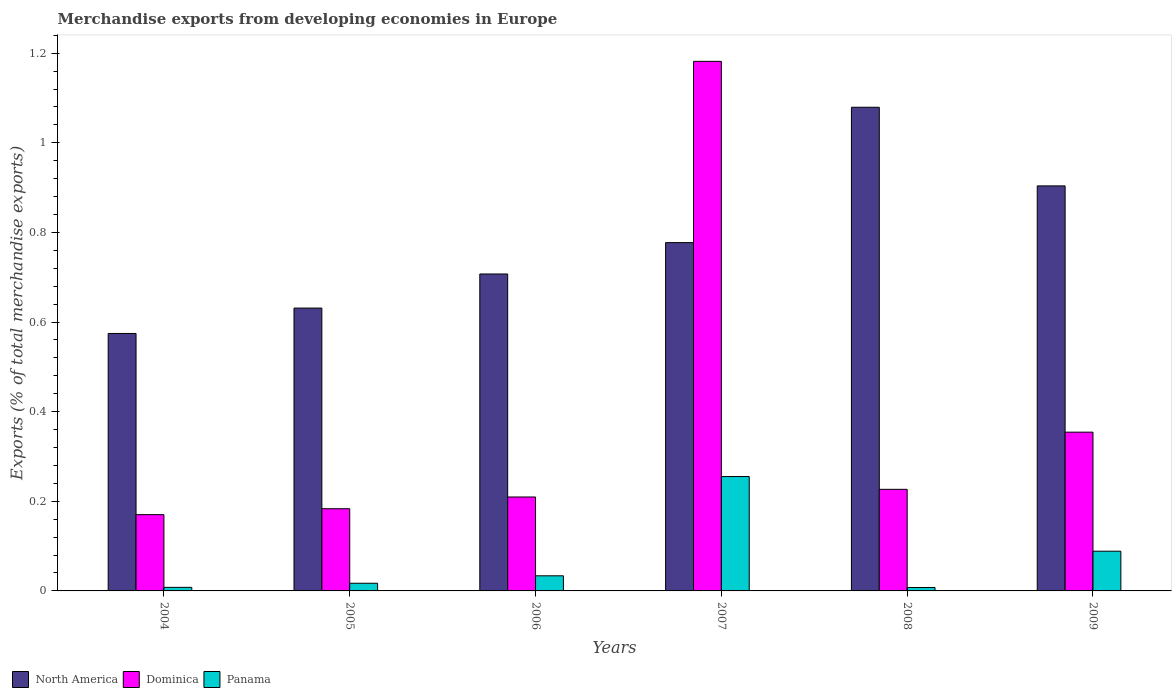Are the number of bars on each tick of the X-axis equal?
Give a very brief answer. Yes. How many bars are there on the 6th tick from the left?
Make the answer very short. 3. How many bars are there on the 6th tick from the right?
Your answer should be compact. 3. What is the percentage of total merchandise exports in Panama in 2007?
Give a very brief answer. 0.26. Across all years, what is the maximum percentage of total merchandise exports in Dominica?
Provide a short and direct response. 1.18. Across all years, what is the minimum percentage of total merchandise exports in Panama?
Provide a short and direct response. 0.01. In which year was the percentage of total merchandise exports in Dominica maximum?
Make the answer very short. 2007. What is the total percentage of total merchandise exports in Panama in the graph?
Provide a succinct answer. 0.41. What is the difference between the percentage of total merchandise exports in North America in 2006 and that in 2009?
Your response must be concise. -0.2. What is the difference between the percentage of total merchandise exports in Dominica in 2008 and the percentage of total merchandise exports in Panama in 2009?
Keep it short and to the point. 0.14. What is the average percentage of total merchandise exports in Dominica per year?
Offer a terse response. 0.39. In the year 2004, what is the difference between the percentage of total merchandise exports in Dominica and percentage of total merchandise exports in Panama?
Ensure brevity in your answer.  0.16. In how many years, is the percentage of total merchandise exports in North America greater than 1 %?
Provide a succinct answer. 1. What is the ratio of the percentage of total merchandise exports in North America in 2004 to that in 2005?
Your answer should be very brief. 0.91. Is the percentage of total merchandise exports in North America in 2005 less than that in 2008?
Your response must be concise. Yes. What is the difference between the highest and the second highest percentage of total merchandise exports in Dominica?
Provide a short and direct response. 0.83. What is the difference between the highest and the lowest percentage of total merchandise exports in Panama?
Offer a terse response. 0.25. In how many years, is the percentage of total merchandise exports in North America greater than the average percentage of total merchandise exports in North America taken over all years?
Offer a very short reply. 2. What does the 2nd bar from the right in 2007 represents?
Provide a succinct answer. Dominica. How many bars are there?
Your answer should be very brief. 18. How many years are there in the graph?
Offer a terse response. 6. What is the difference between two consecutive major ticks on the Y-axis?
Give a very brief answer. 0.2. Are the values on the major ticks of Y-axis written in scientific E-notation?
Offer a terse response. No. Does the graph contain any zero values?
Your answer should be very brief. No. Where does the legend appear in the graph?
Make the answer very short. Bottom left. How many legend labels are there?
Give a very brief answer. 3. How are the legend labels stacked?
Provide a succinct answer. Horizontal. What is the title of the graph?
Give a very brief answer. Merchandise exports from developing economies in Europe. Does "Small states" appear as one of the legend labels in the graph?
Provide a succinct answer. No. What is the label or title of the X-axis?
Give a very brief answer. Years. What is the label or title of the Y-axis?
Your answer should be very brief. Exports (% of total merchandise exports). What is the Exports (% of total merchandise exports) of North America in 2004?
Your answer should be very brief. 0.57. What is the Exports (% of total merchandise exports) of Dominica in 2004?
Your answer should be very brief. 0.17. What is the Exports (% of total merchandise exports) of Panama in 2004?
Make the answer very short. 0.01. What is the Exports (% of total merchandise exports) of North America in 2005?
Ensure brevity in your answer.  0.63. What is the Exports (% of total merchandise exports) of Dominica in 2005?
Ensure brevity in your answer.  0.18. What is the Exports (% of total merchandise exports) in Panama in 2005?
Make the answer very short. 0.02. What is the Exports (% of total merchandise exports) of North America in 2006?
Your answer should be very brief. 0.71. What is the Exports (% of total merchandise exports) of Dominica in 2006?
Offer a very short reply. 0.21. What is the Exports (% of total merchandise exports) in Panama in 2006?
Provide a short and direct response. 0.03. What is the Exports (% of total merchandise exports) in North America in 2007?
Ensure brevity in your answer.  0.78. What is the Exports (% of total merchandise exports) in Dominica in 2007?
Offer a very short reply. 1.18. What is the Exports (% of total merchandise exports) of Panama in 2007?
Keep it short and to the point. 0.26. What is the Exports (% of total merchandise exports) of North America in 2008?
Your answer should be very brief. 1.08. What is the Exports (% of total merchandise exports) of Dominica in 2008?
Provide a succinct answer. 0.23. What is the Exports (% of total merchandise exports) in Panama in 2008?
Give a very brief answer. 0.01. What is the Exports (% of total merchandise exports) of North America in 2009?
Provide a succinct answer. 0.9. What is the Exports (% of total merchandise exports) in Dominica in 2009?
Your response must be concise. 0.35. What is the Exports (% of total merchandise exports) in Panama in 2009?
Ensure brevity in your answer.  0.09. Across all years, what is the maximum Exports (% of total merchandise exports) in North America?
Keep it short and to the point. 1.08. Across all years, what is the maximum Exports (% of total merchandise exports) of Dominica?
Keep it short and to the point. 1.18. Across all years, what is the maximum Exports (% of total merchandise exports) in Panama?
Give a very brief answer. 0.26. Across all years, what is the minimum Exports (% of total merchandise exports) in North America?
Your answer should be very brief. 0.57. Across all years, what is the minimum Exports (% of total merchandise exports) of Dominica?
Keep it short and to the point. 0.17. Across all years, what is the minimum Exports (% of total merchandise exports) in Panama?
Your answer should be very brief. 0.01. What is the total Exports (% of total merchandise exports) in North America in the graph?
Give a very brief answer. 4.67. What is the total Exports (% of total merchandise exports) of Dominica in the graph?
Your answer should be compact. 2.33. What is the total Exports (% of total merchandise exports) of Panama in the graph?
Ensure brevity in your answer.  0.41. What is the difference between the Exports (% of total merchandise exports) in North America in 2004 and that in 2005?
Your response must be concise. -0.06. What is the difference between the Exports (% of total merchandise exports) of Dominica in 2004 and that in 2005?
Offer a terse response. -0.01. What is the difference between the Exports (% of total merchandise exports) of Panama in 2004 and that in 2005?
Your response must be concise. -0.01. What is the difference between the Exports (% of total merchandise exports) in North America in 2004 and that in 2006?
Offer a terse response. -0.13. What is the difference between the Exports (% of total merchandise exports) of Dominica in 2004 and that in 2006?
Offer a very short reply. -0.04. What is the difference between the Exports (% of total merchandise exports) of Panama in 2004 and that in 2006?
Provide a short and direct response. -0.03. What is the difference between the Exports (% of total merchandise exports) in North America in 2004 and that in 2007?
Your answer should be very brief. -0.2. What is the difference between the Exports (% of total merchandise exports) in Dominica in 2004 and that in 2007?
Offer a very short reply. -1.01. What is the difference between the Exports (% of total merchandise exports) in Panama in 2004 and that in 2007?
Offer a terse response. -0.25. What is the difference between the Exports (% of total merchandise exports) of North America in 2004 and that in 2008?
Provide a short and direct response. -0.5. What is the difference between the Exports (% of total merchandise exports) in Dominica in 2004 and that in 2008?
Provide a succinct answer. -0.06. What is the difference between the Exports (% of total merchandise exports) in North America in 2004 and that in 2009?
Give a very brief answer. -0.33. What is the difference between the Exports (% of total merchandise exports) of Dominica in 2004 and that in 2009?
Your answer should be very brief. -0.18. What is the difference between the Exports (% of total merchandise exports) of Panama in 2004 and that in 2009?
Keep it short and to the point. -0.08. What is the difference between the Exports (% of total merchandise exports) in North America in 2005 and that in 2006?
Your answer should be very brief. -0.08. What is the difference between the Exports (% of total merchandise exports) of Dominica in 2005 and that in 2006?
Your answer should be compact. -0.03. What is the difference between the Exports (% of total merchandise exports) in Panama in 2005 and that in 2006?
Make the answer very short. -0.02. What is the difference between the Exports (% of total merchandise exports) of North America in 2005 and that in 2007?
Make the answer very short. -0.15. What is the difference between the Exports (% of total merchandise exports) in Dominica in 2005 and that in 2007?
Offer a very short reply. -1. What is the difference between the Exports (% of total merchandise exports) of Panama in 2005 and that in 2007?
Your response must be concise. -0.24. What is the difference between the Exports (% of total merchandise exports) in North America in 2005 and that in 2008?
Your answer should be compact. -0.45. What is the difference between the Exports (% of total merchandise exports) of Dominica in 2005 and that in 2008?
Give a very brief answer. -0.04. What is the difference between the Exports (% of total merchandise exports) of Panama in 2005 and that in 2008?
Your answer should be very brief. 0.01. What is the difference between the Exports (% of total merchandise exports) of North America in 2005 and that in 2009?
Your answer should be very brief. -0.27. What is the difference between the Exports (% of total merchandise exports) in Dominica in 2005 and that in 2009?
Provide a succinct answer. -0.17. What is the difference between the Exports (% of total merchandise exports) in Panama in 2005 and that in 2009?
Keep it short and to the point. -0.07. What is the difference between the Exports (% of total merchandise exports) of North America in 2006 and that in 2007?
Offer a very short reply. -0.07. What is the difference between the Exports (% of total merchandise exports) of Dominica in 2006 and that in 2007?
Provide a succinct answer. -0.97. What is the difference between the Exports (% of total merchandise exports) in Panama in 2006 and that in 2007?
Keep it short and to the point. -0.22. What is the difference between the Exports (% of total merchandise exports) of North America in 2006 and that in 2008?
Provide a short and direct response. -0.37. What is the difference between the Exports (% of total merchandise exports) of Dominica in 2006 and that in 2008?
Offer a terse response. -0.02. What is the difference between the Exports (% of total merchandise exports) of Panama in 2006 and that in 2008?
Keep it short and to the point. 0.03. What is the difference between the Exports (% of total merchandise exports) of North America in 2006 and that in 2009?
Provide a short and direct response. -0.2. What is the difference between the Exports (% of total merchandise exports) of Dominica in 2006 and that in 2009?
Provide a succinct answer. -0.14. What is the difference between the Exports (% of total merchandise exports) in Panama in 2006 and that in 2009?
Make the answer very short. -0.05. What is the difference between the Exports (% of total merchandise exports) of North America in 2007 and that in 2008?
Your answer should be compact. -0.3. What is the difference between the Exports (% of total merchandise exports) in Dominica in 2007 and that in 2008?
Provide a short and direct response. 0.96. What is the difference between the Exports (% of total merchandise exports) in Panama in 2007 and that in 2008?
Make the answer very short. 0.25. What is the difference between the Exports (% of total merchandise exports) in North America in 2007 and that in 2009?
Your answer should be very brief. -0.13. What is the difference between the Exports (% of total merchandise exports) in Dominica in 2007 and that in 2009?
Provide a succinct answer. 0.83. What is the difference between the Exports (% of total merchandise exports) in Panama in 2007 and that in 2009?
Give a very brief answer. 0.17. What is the difference between the Exports (% of total merchandise exports) of North America in 2008 and that in 2009?
Give a very brief answer. 0.18. What is the difference between the Exports (% of total merchandise exports) of Dominica in 2008 and that in 2009?
Provide a succinct answer. -0.13. What is the difference between the Exports (% of total merchandise exports) of Panama in 2008 and that in 2009?
Provide a short and direct response. -0.08. What is the difference between the Exports (% of total merchandise exports) in North America in 2004 and the Exports (% of total merchandise exports) in Dominica in 2005?
Provide a short and direct response. 0.39. What is the difference between the Exports (% of total merchandise exports) in North America in 2004 and the Exports (% of total merchandise exports) in Panama in 2005?
Provide a short and direct response. 0.56. What is the difference between the Exports (% of total merchandise exports) in Dominica in 2004 and the Exports (% of total merchandise exports) in Panama in 2005?
Provide a succinct answer. 0.15. What is the difference between the Exports (% of total merchandise exports) of North America in 2004 and the Exports (% of total merchandise exports) of Dominica in 2006?
Your answer should be compact. 0.36. What is the difference between the Exports (% of total merchandise exports) in North America in 2004 and the Exports (% of total merchandise exports) in Panama in 2006?
Ensure brevity in your answer.  0.54. What is the difference between the Exports (% of total merchandise exports) of Dominica in 2004 and the Exports (% of total merchandise exports) of Panama in 2006?
Your answer should be very brief. 0.14. What is the difference between the Exports (% of total merchandise exports) of North America in 2004 and the Exports (% of total merchandise exports) of Dominica in 2007?
Provide a succinct answer. -0.61. What is the difference between the Exports (% of total merchandise exports) in North America in 2004 and the Exports (% of total merchandise exports) in Panama in 2007?
Provide a succinct answer. 0.32. What is the difference between the Exports (% of total merchandise exports) of Dominica in 2004 and the Exports (% of total merchandise exports) of Panama in 2007?
Keep it short and to the point. -0.09. What is the difference between the Exports (% of total merchandise exports) of North America in 2004 and the Exports (% of total merchandise exports) of Dominica in 2008?
Offer a terse response. 0.35. What is the difference between the Exports (% of total merchandise exports) of North America in 2004 and the Exports (% of total merchandise exports) of Panama in 2008?
Your answer should be very brief. 0.57. What is the difference between the Exports (% of total merchandise exports) of Dominica in 2004 and the Exports (% of total merchandise exports) of Panama in 2008?
Offer a very short reply. 0.16. What is the difference between the Exports (% of total merchandise exports) of North America in 2004 and the Exports (% of total merchandise exports) of Dominica in 2009?
Make the answer very short. 0.22. What is the difference between the Exports (% of total merchandise exports) of North America in 2004 and the Exports (% of total merchandise exports) of Panama in 2009?
Offer a terse response. 0.49. What is the difference between the Exports (% of total merchandise exports) of Dominica in 2004 and the Exports (% of total merchandise exports) of Panama in 2009?
Your answer should be very brief. 0.08. What is the difference between the Exports (% of total merchandise exports) in North America in 2005 and the Exports (% of total merchandise exports) in Dominica in 2006?
Offer a terse response. 0.42. What is the difference between the Exports (% of total merchandise exports) of North America in 2005 and the Exports (% of total merchandise exports) of Panama in 2006?
Keep it short and to the point. 0.6. What is the difference between the Exports (% of total merchandise exports) of Dominica in 2005 and the Exports (% of total merchandise exports) of Panama in 2006?
Give a very brief answer. 0.15. What is the difference between the Exports (% of total merchandise exports) of North America in 2005 and the Exports (% of total merchandise exports) of Dominica in 2007?
Your response must be concise. -0.55. What is the difference between the Exports (% of total merchandise exports) of North America in 2005 and the Exports (% of total merchandise exports) of Panama in 2007?
Offer a very short reply. 0.38. What is the difference between the Exports (% of total merchandise exports) of Dominica in 2005 and the Exports (% of total merchandise exports) of Panama in 2007?
Make the answer very short. -0.07. What is the difference between the Exports (% of total merchandise exports) in North America in 2005 and the Exports (% of total merchandise exports) in Dominica in 2008?
Provide a succinct answer. 0.4. What is the difference between the Exports (% of total merchandise exports) in North America in 2005 and the Exports (% of total merchandise exports) in Panama in 2008?
Your answer should be compact. 0.62. What is the difference between the Exports (% of total merchandise exports) in Dominica in 2005 and the Exports (% of total merchandise exports) in Panama in 2008?
Keep it short and to the point. 0.18. What is the difference between the Exports (% of total merchandise exports) in North America in 2005 and the Exports (% of total merchandise exports) in Dominica in 2009?
Keep it short and to the point. 0.28. What is the difference between the Exports (% of total merchandise exports) of North America in 2005 and the Exports (% of total merchandise exports) of Panama in 2009?
Keep it short and to the point. 0.54. What is the difference between the Exports (% of total merchandise exports) in Dominica in 2005 and the Exports (% of total merchandise exports) in Panama in 2009?
Make the answer very short. 0.09. What is the difference between the Exports (% of total merchandise exports) of North America in 2006 and the Exports (% of total merchandise exports) of Dominica in 2007?
Provide a short and direct response. -0.47. What is the difference between the Exports (% of total merchandise exports) of North America in 2006 and the Exports (% of total merchandise exports) of Panama in 2007?
Make the answer very short. 0.45. What is the difference between the Exports (% of total merchandise exports) of Dominica in 2006 and the Exports (% of total merchandise exports) of Panama in 2007?
Keep it short and to the point. -0.05. What is the difference between the Exports (% of total merchandise exports) of North America in 2006 and the Exports (% of total merchandise exports) of Dominica in 2008?
Offer a very short reply. 0.48. What is the difference between the Exports (% of total merchandise exports) in North America in 2006 and the Exports (% of total merchandise exports) in Panama in 2008?
Your response must be concise. 0.7. What is the difference between the Exports (% of total merchandise exports) in Dominica in 2006 and the Exports (% of total merchandise exports) in Panama in 2008?
Your answer should be very brief. 0.2. What is the difference between the Exports (% of total merchandise exports) in North America in 2006 and the Exports (% of total merchandise exports) in Dominica in 2009?
Make the answer very short. 0.35. What is the difference between the Exports (% of total merchandise exports) of North America in 2006 and the Exports (% of total merchandise exports) of Panama in 2009?
Offer a terse response. 0.62. What is the difference between the Exports (% of total merchandise exports) in Dominica in 2006 and the Exports (% of total merchandise exports) in Panama in 2009?
Keep it short and to the point. 0.12. What is the difference between the Exports (% of total merchandise exports) in North America in 2007 and the Exports (% of total merchandise exports) in Dominica in 2008?
Make the answer very short. 0.55. What is the difference between the Exports (% of total merchandise exports) in North America in 2007 and the Exports (% of total merchandise exports) in Panama in 2008?
Provide a succinct answer. 0.77. What is the difference between the Exports (% of total merchandise exports) of Dominica in 2007 and the Exports (% of total merchandise exports) of Panama in 2008?
Your answer should be compact. 1.17. What is the difference between the Exports (% of total merchandise exports) in North America in 2007 and the Exports (% of total merchandise exports) in Dominica in 2009?
Your answer should be compact. 0.42. What is the difference between the Exports (% of total merchandise exports) in North America in 2007 and the Exports (% of total merchandise exports) in Panama in 2009?
Offer a very short reply. 0.69. What is the difference between the Exports (% of total merchandise exports) in Dominica in 2007 and the Exports (% of total merchandise exports) in Panama in 2009?
Your answer should be very brief. 1.09. What is the difference between the Exports (% of total merchandise exports) in North America in 2008 and the Exports (% of total merchandise exports) in Dominica in 2009?
Provide a short and direct response. 0.73. What is the difference between the Exports (% of total merchandise exports) in North America in 2008 and the Exports (% of total merchandise exports) in Panama in 2009?
Provide a succinct answer. 0.99. What is the difference between the Exports (% of total merchandise exports) in Dominica in 2008 and the Exports (% of total merchandise exports) in Panama in 2009?
Your answer should be compact. 0.14. What is the average Exports (% of total merchandise exports) of North America per year?
Offer a very short reply. 0.78. What is the average Exports (% of total merchandise exports) of Dominica per year?
Your answer should be compact. 0.39. What is the average Exports (% of total merchandise exports) of Panama per year?
Provide a succinct answer. 0.07. In the year 2004, what is the difference between the Exports (% of total merchandise exports) in North America and Exports (% of total merchandise exports) in Dominica?
Your response must be concise. 0.4. In the year 2004, what is the difference between the Exports (% of total merchandise exports) in North America and Exports (% of total merchandise exports) in Panama?
Offer a very short reply. 0.57. In the year 2004, what is the difference between the Exports (% of total merchandise exports) of Dominica and Exports (% of total merchandise exports) of Panama?
Offer a very short reply. 0.16. In the year 2005, what is the difference between the Exports (% of total merchandise exports) in North America and Exports (% of total merchandise exports) in Dominica?
Provide a short and direct response. 0.45. In the year 2005, what is the difference between the Exports (% of total merchandise exports) in North America and Exports (% of total merchandise exports) in Panama?
Your response must be concise. 0.61. In the year 2005, what is the difference between the Exports (% of total merchandise exports) of Dominica and Exports (% of total merchandise exports) of Panama?
Your response must be concise. 0.17. In the year 2006, what is the difference between the Exports (% of total merchandise exports) in North America and Exports (% of total merchandise exports) in Dominica?
Make the answer very short. 0.5. In the year 2006, what is the difference between the Exports (% of total merchandise exports) in North America and Exports (% of total merchandise exports) in Panama?
Give a very brief answer. 0.67. In the year 2006, what is the difference between the Exports (% of total merchandise exports) of Dominica and Exports (% of total merchandise exports) of Panama?
Provide a succinct answer. 0.18. In the year 2007, what is the difference between the Exports (% of total merchandise exports) of North America and Exports (% of total merchandise exports) of Dominica?
Your response must be concise. -0.4. In the year 2007, what is the difference between the Exports (% of total merchandise exports) of North America and Exports (% of total merchandise exports) of Panama?
Ensure brevity in your answer.  0.52. In the year 2007, what is the difference between the Exports (% of total merchandise exports) of Dominica and Exports (% of total merchandise exports) of Panama?
Ensure brevity in your answer.  0.93. In the year 2008, what is the difference between the Exports (% of total merchandise exports) in North America and Exports (% of total merchandise exports) in Dominica?
Provide a short and direct response. 0.85. In the year 2008, what is the difference between the Exports (% of total merchandise exports) of North America and Exports (% of total merchandise exports) of Panama?
Your answer should be compact. 1.07. In the year 2008, what is the difference between the Exports (% of total merchandise exports) in Dominica and Exports (% of total merchandise exports) in Panama?
Your response must be concise. 0.22. In the year 2009, what is the difference between the Exports (% of total merchandise exports) of North America and Exports (% of total merchandise exports) of Dominica?
Offer a very short reply. 0.55. In the year 2009, what is the difference between the Exports (% of total merchandise exports) of North America and Exports (% of total merchandise exports) of Panama?
Make the answer very short. 0.82. In the year 2009, what is the difference between the Exports (% of total merchandise exports) in Dominica and Exports (% of total merchandise exports) in Panama?
Your response must be concise. 0.27. What is the ratio of the Exports (% of total merchandise exports) in North America in 2004 to that in 2005?
Offer a very short reply. 0.91. What is the ratio of the Exports (% of total merchandise exports) in Dominica in 2004 to that in 2005?
Your response must be concise. 0.93. What is the ratio of the Exports (% of total merchandise exports) of Panama in 2004 to that in 2005?
Your answer should be compact. 0.47. What is the ratio of the Exports (% of total merchandise exports) of North America in 2004 to that in 2006?
Make the answer very short. 0.81. What is the ratio of the Exports (% of total merchandise exports) of Dominica in 2004 to that in 2006?
Provide a short and direct response. 0.81. What is the ratio of the Exports (% of total merchandise exports) of Panama in 2004 to that in 2006?
Offer a terse response. 0.24. What is the ratio of the Exports (% of total merchandise exports) of North America in 2004 to that in 2007?
Give a very brief answer. 0.74. What is the ratio of the Exports (% of total merchandise exports) in Dominica in 2004 to that in 2007?
Give a very brief answer. 0.14. What is the ratio of the Exports (% of total merchandise exports) in Panama in 2004 to that in 2007?
Offer a terse response. 0.03. What is the ratio of the Exports (% of total merchandise exports) in North America in 2004 to that in 2008?
Make the answer very short. 0.53. What is the ratio of the Exports (% of total merchandise exports) in Dominica in 2004 to that in 2008?
Make the answer very short. 0.75. What is the ratio of the Exports (% of total merchandise exports) in Panama in 2004 to that in 2008?
Provide a succinct answer. 1.04. What is the ratio of the Exports (% of total merchandise exports) of North America in 2004 to that in 2009?
Make the answer very short. 0.64. What is the ratio of the Exports (% of total merchandise exports) of Dominica in 2004 to that in 2009?
Offer a terse response. 0.48. What is the ratio of the Exports (% of total merchandise exports) in Panama in 2004 to that in 2009?
Make the answer very short. 0.09. What is the ratio of the Exports (% of total merchandise exports) in North America in 2005 to that in 2006?
Ensure brevity in your answer.  0.89. What is the ratio of the Exports (% of total merchandise exports) of Dominica in 2005 to that in 2006?
Give a very brief answer. 0.88. What is the ratio of the Exports (% of total merchandise exports) of Panama in 2005 to that in 2006?
Provide a succinct answer. 0.51. What is the ratio of the Exports (% of total merchandise exports) of North America in 2005 to that in 2007?
Your answer should be very brief. 0.81. What is the ratio of the Exports (% of total merchandise exports) in Dominica in 2005 to that in 2007?
Your answer should be very brief. 0.16. What is the ratio of the Exports (% of total merchandise exports) in Panama in 2005 to that in 2007?
Keep it short and to the point. 0.07. What is the ratio of the Exports (% of total merchandise exports) in North America in 2005 to that in 2008?
Keep it short and to the point. 0.58. What is the ratio of the Exports (% of total merchandise exports) in Dominica in 2005 to that in 2008?
Offer a very short reply. 0.81. What is the ratio of the Exports (% of total merchandise exports) of Panama in 2005 to that in 2008?
Provide a short and direct response. 2.24. What is the ratio of the Exports (% of total merchandise exports) of North America in 2005 to that in 2009?
Give a very brief answer. 0.7. What is the ratio of the Exports (% of total merchandise exports) of Dominica in 2005 to that in 2009?
Provide a short and direct response. 0.52. What is the ratio of the Exports (% of total merchandise exports) in Panama in 2005 to that in 2009?
Offer a very short reply. 0.19. What is the ratio of the Exports (% of total merchandise exports) in North America in 2006 to that in 2007?
Your response must be concise. 0.91. What is the ratio of the Exports (% of total merchandise exports) of Dominica in 2006 to that in 2007?
Keep it short and to the point. 0.18. What is the ratio of the Exports (% of total merchandise exports) of Panama in 2006 to that in 2007?
Give a very brief answer. 0.13. What is the ratio of the Exports (% of total merchandise exports) of North America in 2006 to that in 2008?
Make the answer very short. 0.66. What is the ratio of the Exports (% of total merchandise exports) of Dominica in 2006 to that in 2008?
Provide a short and direct response. 0.92. What is the ratio of the Exports (% of total merchandise exports) in Panama in 2006 to that in 2008?
Give a very brief answer. 4.42. What is the ratio of the Exports (% of total merchandise exports) of North America in 2006 to that in 2009?
Give a very brief answer. 0.78. What is the ratio of the Exports (% of total merchandise exports) in Dominica in 2006 to that in 2009?
Your response must be concise. 0.59. What is the ratio of the Exports (% of total merchandise exports) in Panama in 2006 to that in 2009?
Provide a succinct answer. 0.38. What is the ratio of the Exports (% of total merchandise exports) of North America in 2007 to that in 2008?
Offer a terse response. 0.72. What is the ratio of the Exports (% of total merchandise exports) in Dominica in 2007 to that in 2008?
Keep it short and to the point. 5.21. What is the ratio of the Exports (% of total merchandise exports) of Panama in 2007 to that in 2008?
Your answer should be compact. 33.42. What is the ratio of the Exports (% of total merchandise exports) in North America in 2007 to that in 2009?
Give a very brief answer. 0.86. What is the ratio of the Exports (% of total merchandise exports) of Dominica in 2007 to that in 2009?
Offer a terse response. 3.34. What is the ratio of the Exports (% of total merchandise exports) in Panama in 2007 to that in 2009?
Give a very brief answer. 2.88. What is the ratio of the Exports (% of total merchandise exports) of North America in 2008 to that in 2009?
Your answer should be compact. 1.19. What is the ratio of the Exports (% of total merchandise exports) in Dominica in 2008 to that in 2009?
Make the answer very short. 0.64. What is the ratio of the Exports (% of total merchandise exports) in Panama in 2008 to that in 2009?
Give a very brief answer. 0.09. What is the difference between the highest and the second highest Exports (% of total merchandise exports) in North America?
Ensure brevity in your answer.  0.18. What is the difference between the highest and the second highest Exports (% of total merchandise exports) in Dominica?
Provide a short and direct response. 0.83. What is the difference between the highest and the second highest Exports (% of total merchandise exports) in Panama?
Give a very brief answer. 0.17. What is the difference between the highest and the lowest Exports (% of total merchandise exports) of North America?
Your answer should be compact. 0.5. What is the difference between the highest and the lowest Exports (% of total merchandise exports) of Dominica?
Keep it short and to the point. 1.01. What is the difference between the highest and the lowest Exports (% of total merchandise exports) in Panama?
Your answer should be compact. 0.25. 